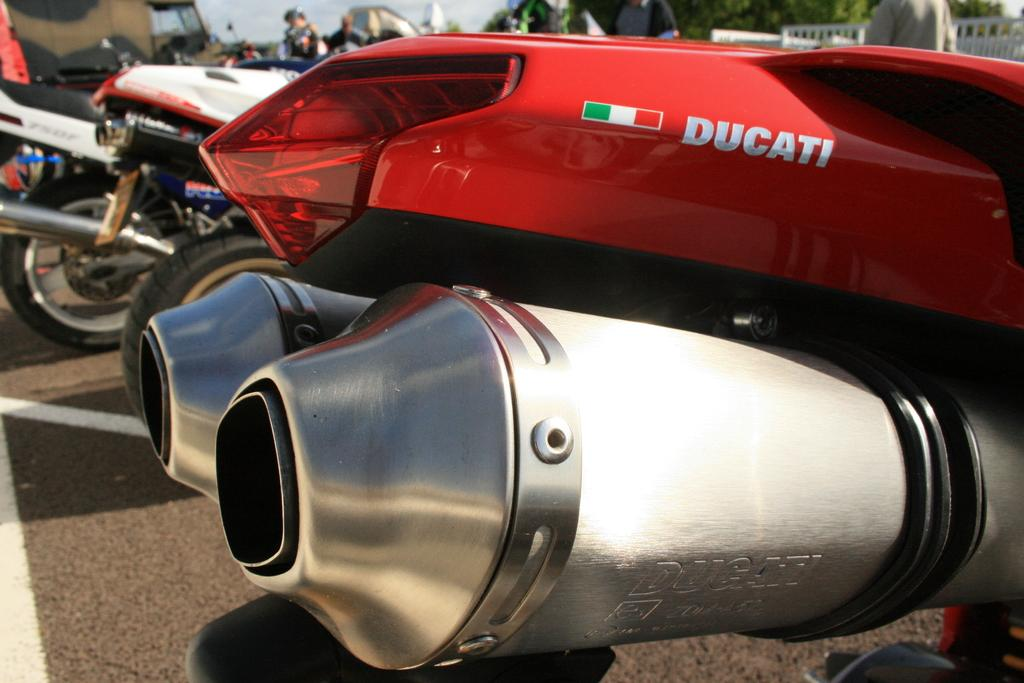What is the main subject in the foreground of the image? There is a vehicle in the foreground of the image. What can be seen in the background of the image? There are vehicles, persons, trees, and a railing in the background of the image. What is at the bottom of the image? There is a road at the bottom of the image. What type of furniture can be seen in the image? There is no furniture present in the image. Can you see a goose in the image? There is no goose present in the image. 